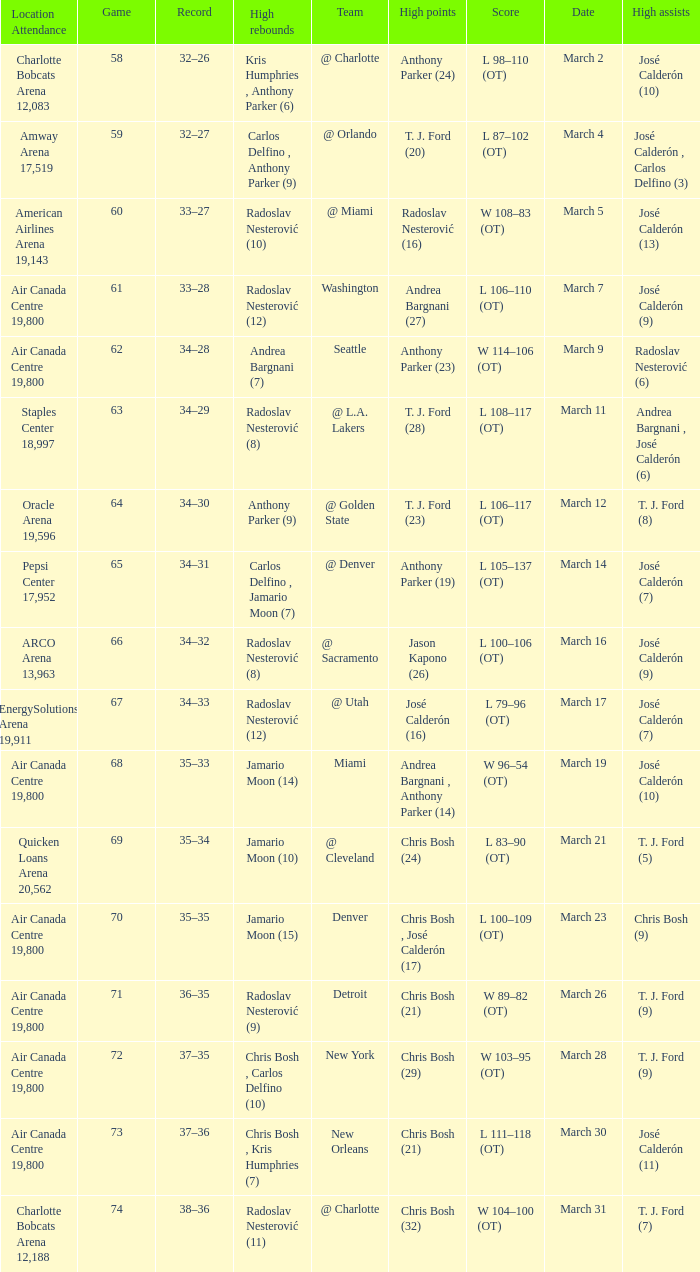How many attended the game on march 16 after over 64 games? ARCO Arena 13,963. 